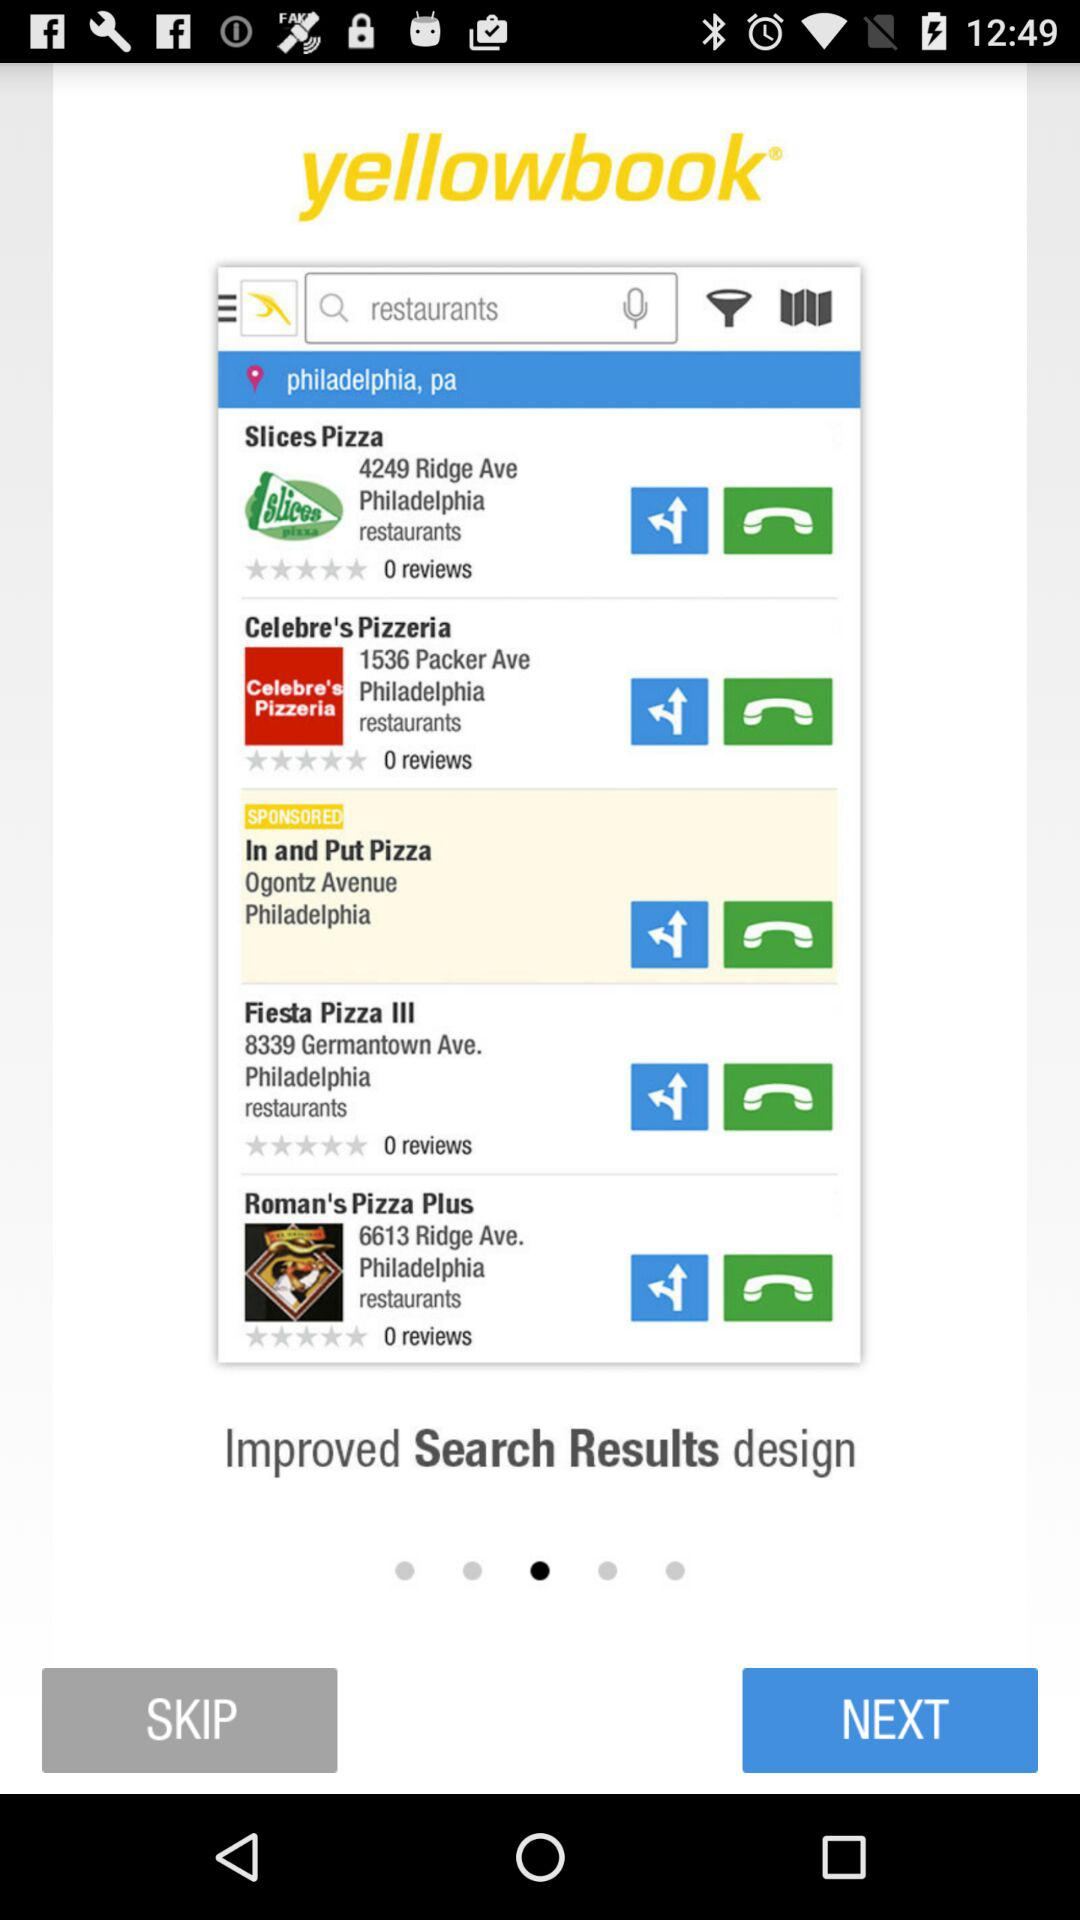What is the app name? The app name is "yellowbook". 